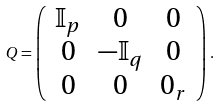<formula> <loc_0><loc_0><loc_500><loc_500>Q = \left ( \begin{array} { c c c } \mathbb { I } _ { p } & 0 & 0 \\ 0 & - \mathbb { I } _ { q } & 0 \\ 0 & 0 & 0 _ { r } \end{array} \right ) \, .</formula> 